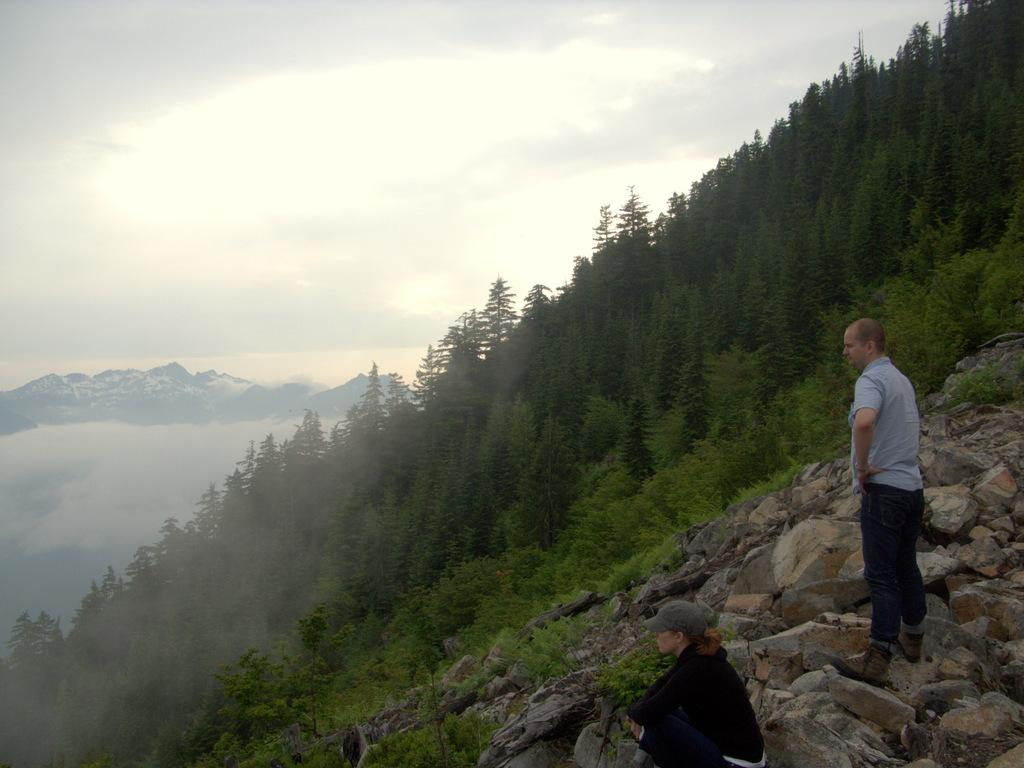What is the man doing in the image? The man is standing on a hill in the image. What is the lady doing in the image? The lady is sitting on rocks at the bottom of the hill. What can be seen in the background of the image? There are hills and the sky visible in the background of the image. What type of orange furniture can be seen in the image? There is no orange furniture present in the image. Is there a chair visible in the image? There is no chair visible in the image. 